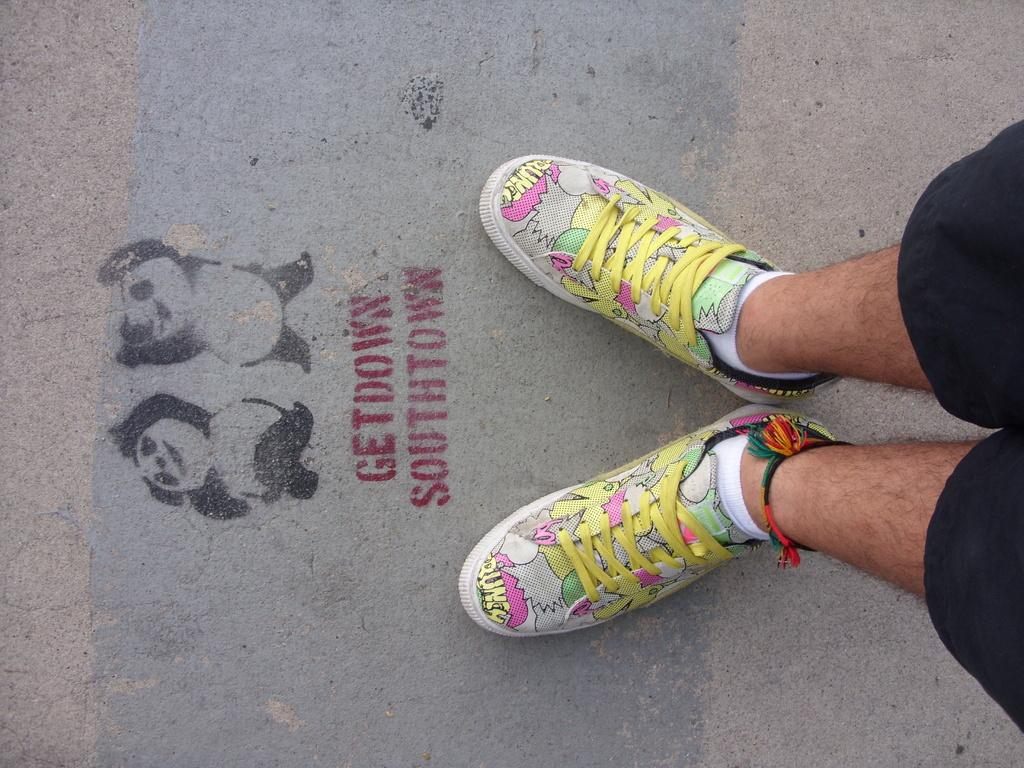What can be seen on the right side of the image? There are two legs of a person on the right side of the image. What is present on the road in the image? There is paint and text on the road. What type of spoon is being used for acoustics in the image? There is no spoon or acoustics-related activity present in the image. 